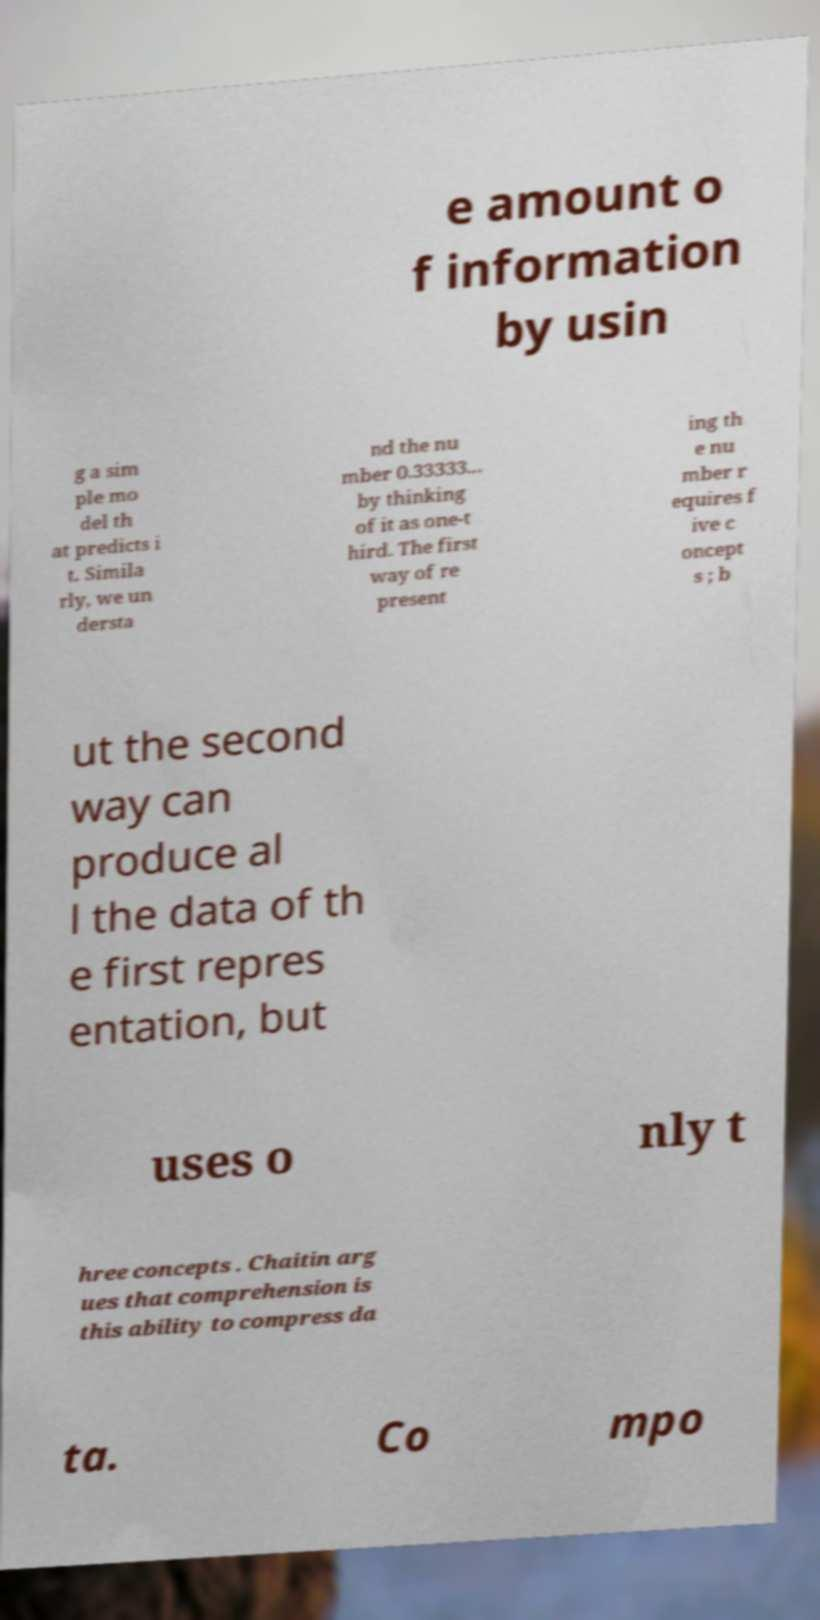Could you extract and type out the text from this image? e amount o f information by usin g a sim ple mo del th at predicts i t. Simila rly, we un dersta nd the nu mber 0.33333... by thinking of it as one-t hird. The first way of re present ing th e nu mber r equires f ive c oncept s ; b ut the second way can produce al l the data of th e first repres entation, but uses o nly t hree concepts . Chaitin arg ues that comprehension is this ability to compress da ta. Co mpo 